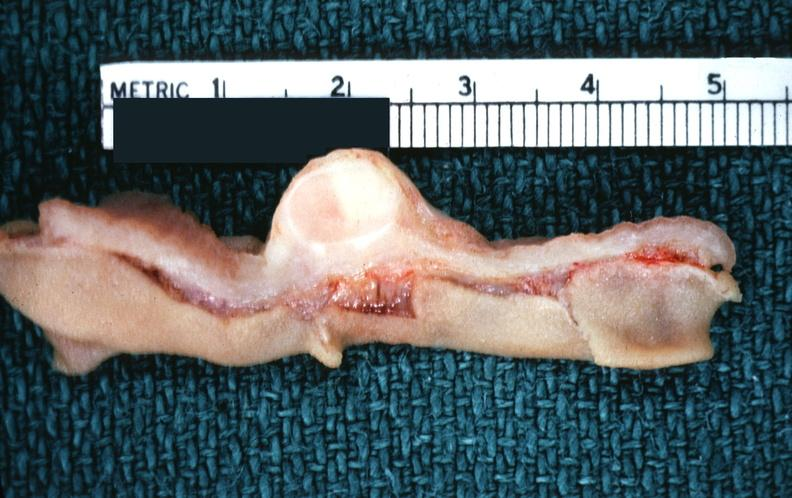where does this belong to?
Answer the question using a single word or phrase. Gastrointestinal system 